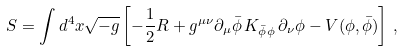Convert formula to latex. <formula><loc_0><loc_0><loc_500><loc_500>S = \int d ^ { 4 } x \sqrt { - g } \left [ - \frac { 1 } { 2 } R + g ^ { \mu \nu } \partial _ { \mu } \bar { \phi } \, K _ { \bar { \phi } \phi } \, \partial _ { \nu } \phi - V ( \phi , \bar { \phi } ) \right ] \, ,</formula> 